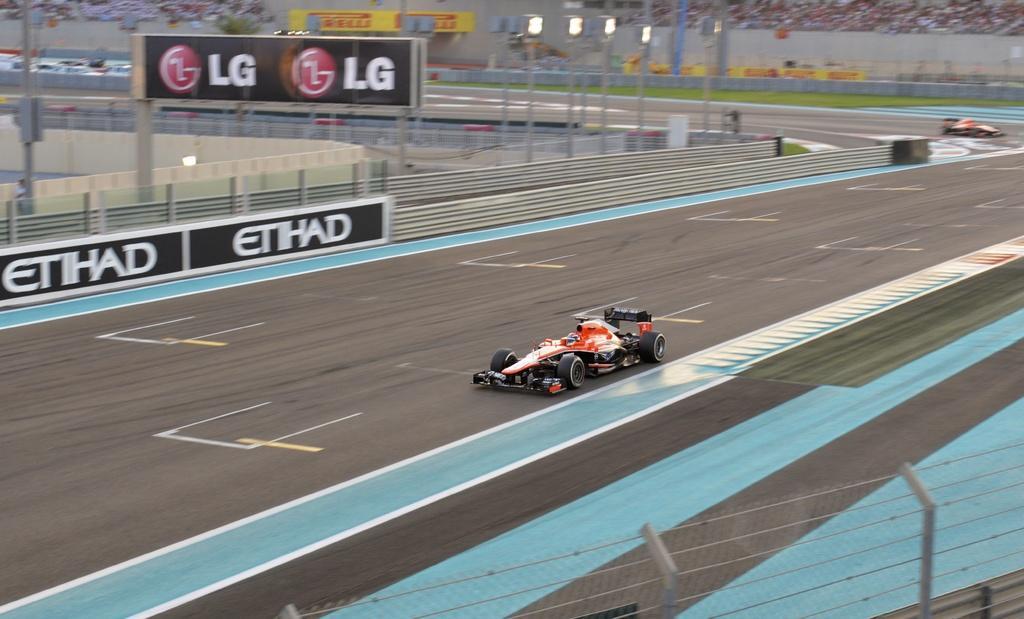Can you describe this image briefly? As we can see in the image there are carts, fence, banner, lights and group of people in the background. 